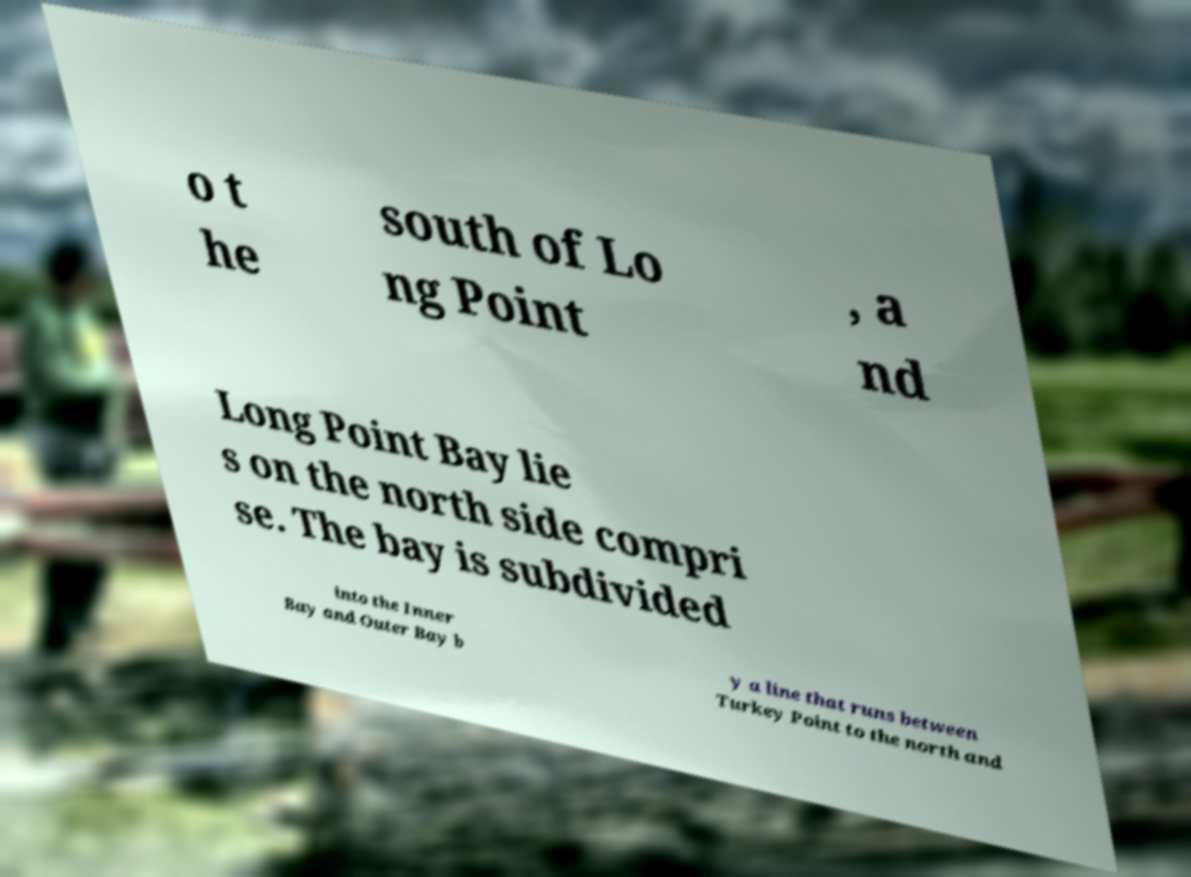There's text embedded in this image that I need extracted. Can you transcribe it verbatim? o t he south of Lo ng Point , a nd Long Point Bay lie s on the north side compri se. The bay is subdivided into the Inner Bay and Outer Bay b y a line that runs between Turkey Point to the north and 